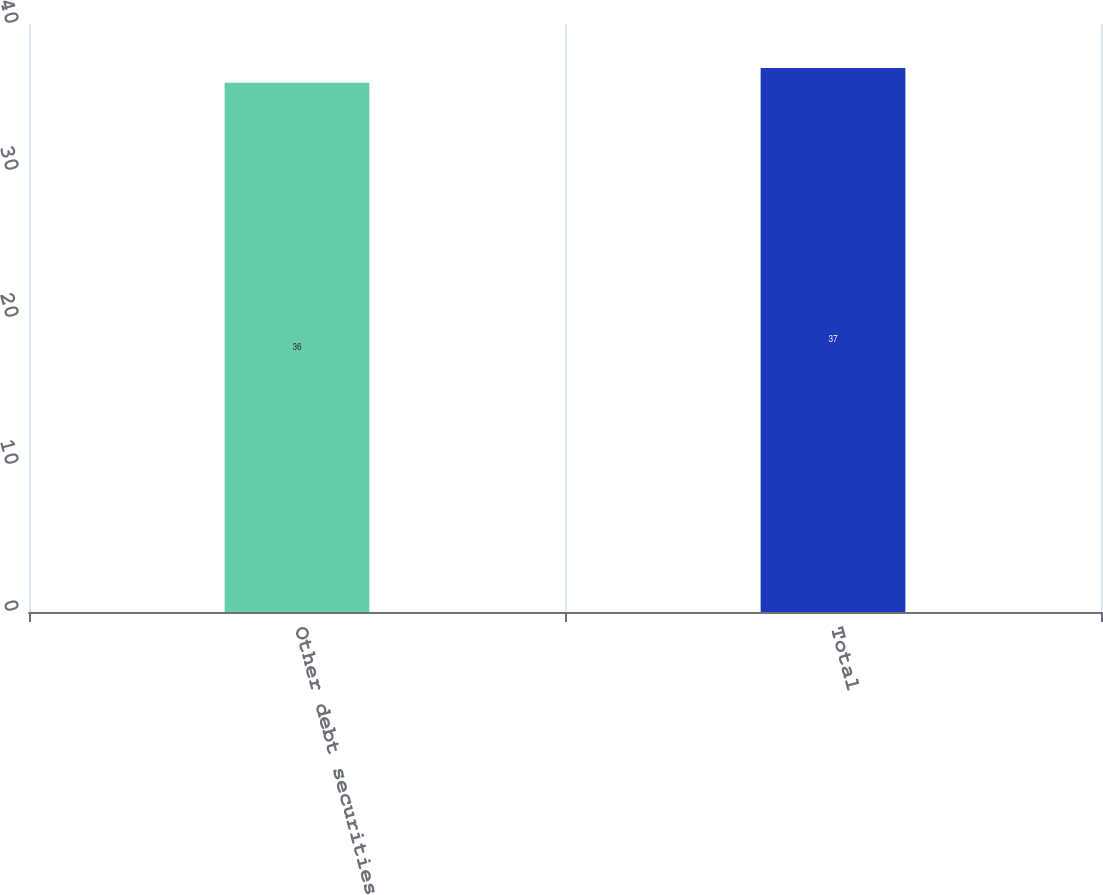Convert chart. <chart><loc_0><loc_0><loc_500><loc_500><bar_chart><fcel>Other debt securities<fcel>Total<nl><fcel>36<fcel>37<nl></chart> 